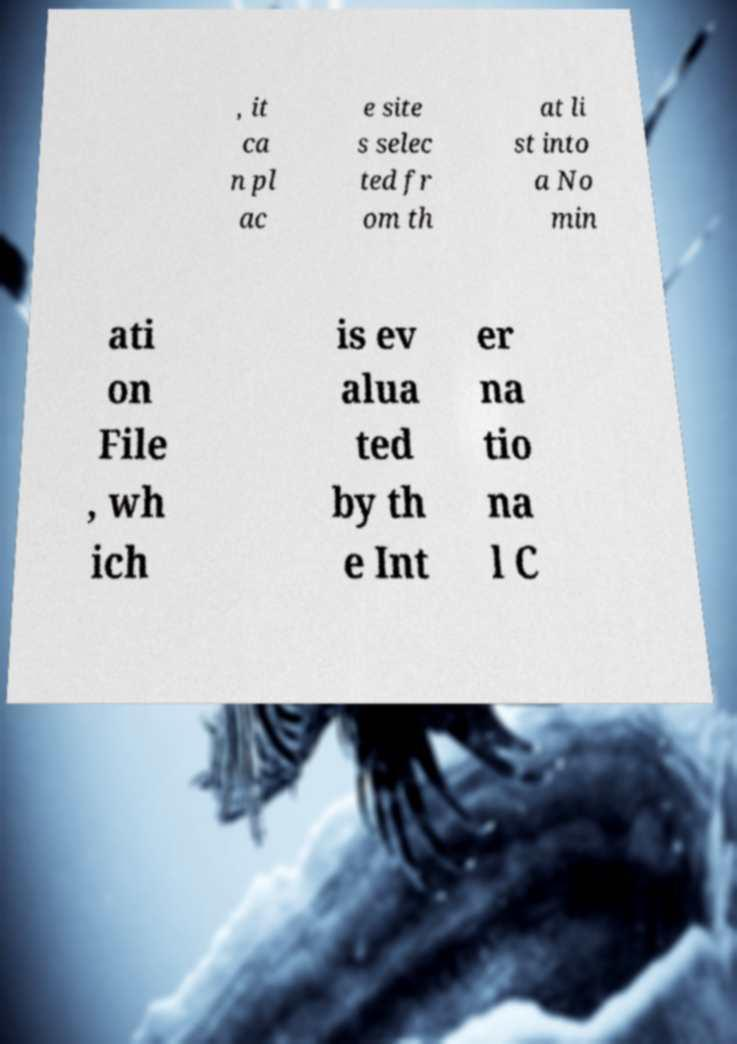Please read and relay the text visible in this image. What does it say? , it ca n pl ac e site s selec ted fr om th at li st into a No min ati on File , wh ich is ev alua ted by th e Int er na tio na l C 